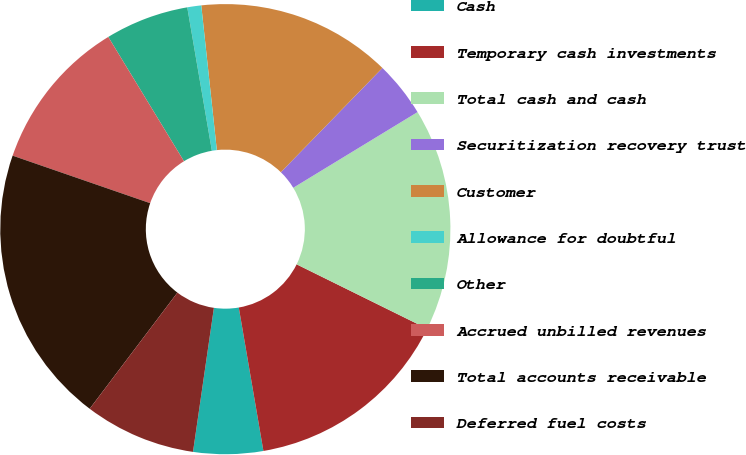Convert chart. <chart><loc_0><loc_0><loc_500><loc_500><pie_chart><fcel>Cash<fcel>Temporary cash investments<fcel>Total cash and cash<fcel>Securitization recovery trust<fcel>Customer<fcel>Allowance for doubtful<fcel>Other<fcel>Accrued unbilled revenues<fcel>Total accounts receivable<fcel>Deferred fuel costs<nl><fcel>5.0%<fcel>15.0%<fcel>16.0%<fcel>4.0%<fcel>14.0%<fcel>1.0%<fcel>6.0%<fcel>11.0%<fcel>20.0%<fcel>8.0%<nl></chart> 